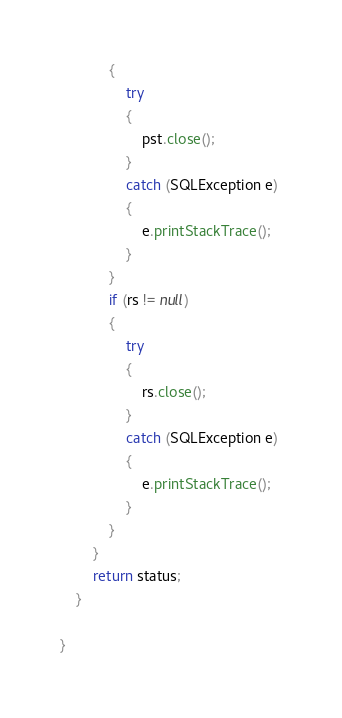Convert code to text. <code><loc_0><loc_0><loc_500><loc_500><_Java_>            {
                try
                {
                    pst.close();
                } 
                catch (SQLException e) 
                {
                    e.printStackTrace();
                }
            }
            if (rs != null) 
            {
                try
                {
                    rs.close();
                } 
                catch (SQLException e)
                {
                    e.printStackTrace();
                }
            }
        }
        return status;
    }

}
</code> 